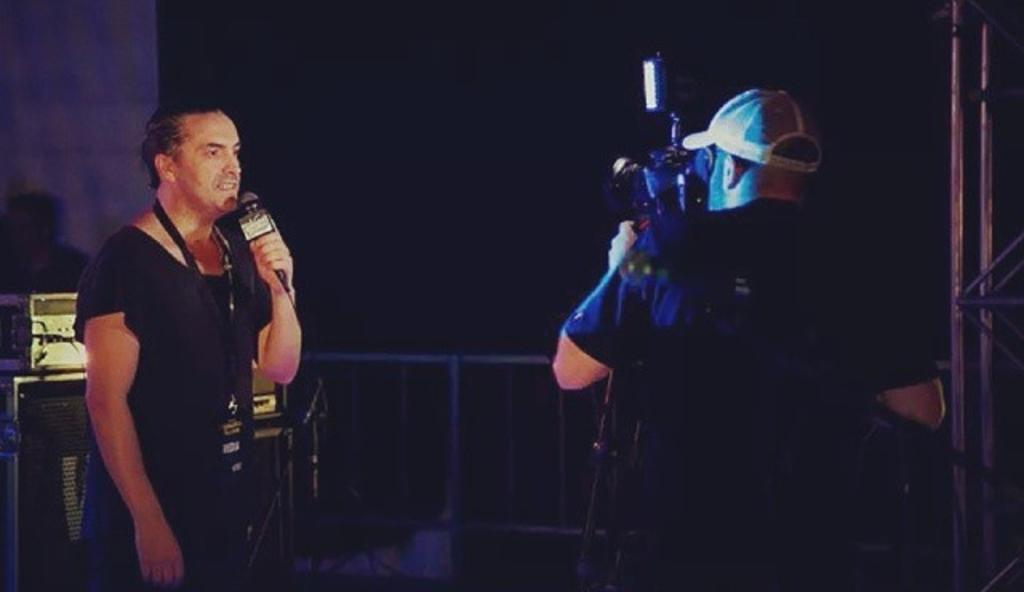How many persons can be seen in the image? There are persons in the image, but the exact number is not specified. What object is present that is typically used for amplifying sound? There is a microphone in the image. What type of objects can be seen in the background of the image? There are iron objects and other objects in the background of the image. What book is being read by the person in the image? There is no book present in the image. What type of pin can be seen holding up the person's hair in the image? There is no person with hair in the image, nor is there a pin present. 